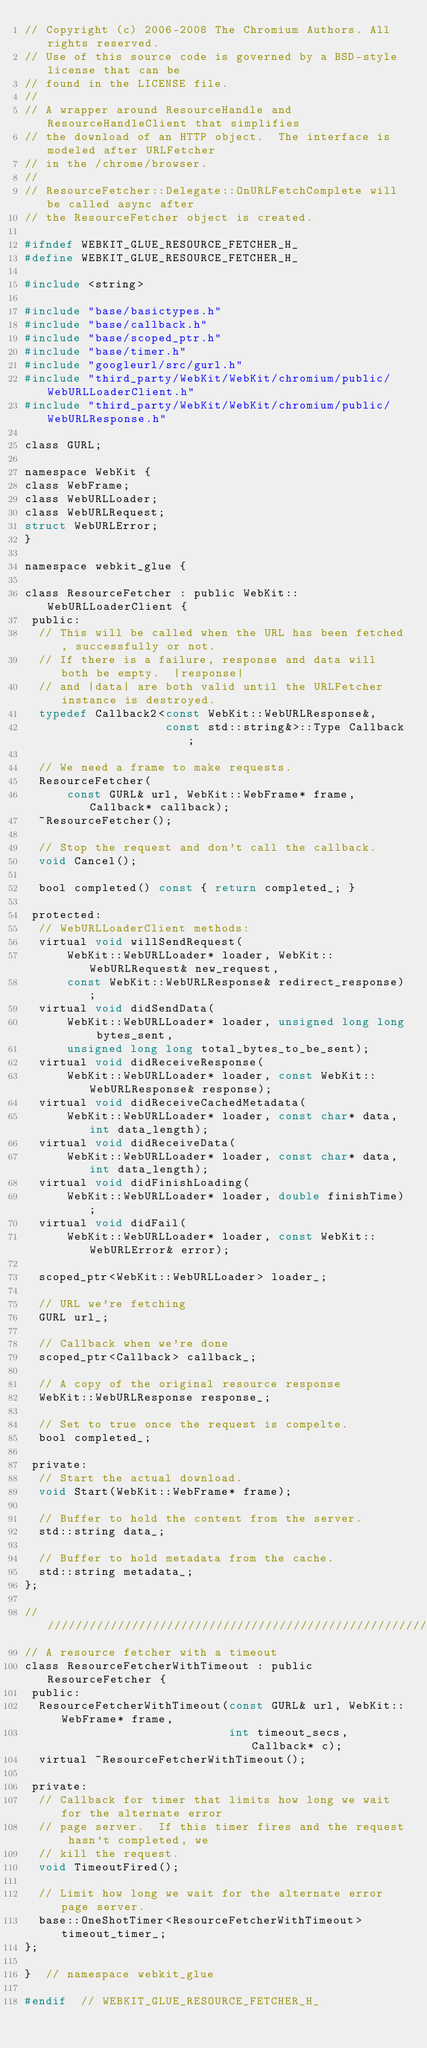Convert code to text. <code><loc_0><loc_0><loc_500><loc_500><_C_>// Copyright (c) 2006-2008 The Chromium Authors. All rights reserved.
// Use of this source code is governed by a BSD-style license that can be
// found in the LICENSE file.
//
// A wrapper around ResourceHandle and ResourceHandleClient that simplifies
// the download of an HTTP object.  The interface is modeled after URLFetcher
// in the /chrome/browser.
//
// ResourceFetcher::Delegate::OnURLFetchComplete will be called async after
// the ResourceFetcher object is created.

#ifndef WEBKIT_GLUE_RESOURCE_FETCHER_H_
#define WEBKIT_GLUE_RESOURCE_FETCHER_H_

#include <string>

#include "base/basictypes.h"
#include "base/callback.h"
#include "base/scoped_ptr.h"
#include "base/timer.h"
#include "googleurl/src/gurl.h"
#include "third_party/WebKit/WebKit/chromium/public/WebURLLoaderClient.h"
#include "third_party/WebKit/WebKit/chromium/public/WebURLResponse.h"

class GURL;

namespace WebKit {
class WebFrame;
class WebURLLoader;
class WebURLRequest;
struct WebURLError;
}

namespace webkit_glue {

class ResourceFetcher : public WebKit::WebURLLoaderClient {
 public:
  // This will be called when the URL has been fetched, successfully or not.
  // If there is a failure, response and data will both be empty.  |response|
  // and |data| are both valid until the URLFetcher instance is destroyed.
  typedef Callback2<const WebKit::WebURLResponse&,
                    const std::string&>::Type Callback;

  // We need a frame to make requests.
  ResourceFetcher(
      const GURL& url, WebKit::WebFrame* frame, Callback* callback);
  ~ResourceFetcher();

  // Stop the request and don't call the callback.
  void Cancel();

  bool completed() const { return completed_; }

 protected:
  // WebURLLoaderClient methods:
  virtual void willSendRequest(
      WebKit::WebURLLoader* loader, WebKit::WebURLRequest& new_request,
      const WebKit::WebURLResponse& redirect_response);
  virtual void didSendData(
      WebKit::WebURLLoader* loader, unsigned long long bytes_sent,
      unsigned long long total_bytes_to_be_sent);
  virtual void didReceiveResponse(
      WebKit::WebURLLoader* loader, const WebKit::WebURLResponse& response);
  virtual void didReceiveCachedMetadata(
      WebKit::WebURLLoader* loader, const char* data, int data_length);
  virtual void didReceiveData(
      WebKit::WebURLLoader* loader, const char* data, int data_length);
  virtual void didFinishLoading(
      WebKit::WebURLLoader* loader, double finishTime);
  virtual void didFail(
      WebKit::WebURLLoader* loader, const WebKit::WebURLError& error);

  scoped_ptr<WebKit::WebURLLoader> loader_;

  // URL we're fetching
  GURL url_;

  // Callback when we're done
  scoped_ptr<Callback> callback_;

  // A copy of the original resource response
  WebKit::WebURLResponse response_;

  // Set to true once the request is compelte.
  bool completed_;

 private:
  // Start the actual download.
  void Start(WebKit::WebFrame* frame);

  // Buffer to hold the content from the server.
  std::string data_;

  // Buffer to hold metadata from the cache.
  std::string metadata_;
};

/////////////////////////////////////////////////////////////////////////////
// A resource fetcher with a timeout
class ResourceFetcherWithTimeout : public ResourceFetcher {
 public:
  ResourceFetcherWithTimeout(const GURL& url, WebKit::WebFrame* frame,
                             int timeout_secs, Callback* c);
  virtual ~ResourceFetcherWithTimeout();

 private:
  // Callback for timer that limits how long we wait for the alternate error
  // page server.  If this timer fires and the request hasn't completed, we
  // kill the request.
  void TimeoutFired();

  // Limit how long we wait for the alternate error page server.
  base::OneShotTimer<ResourceFetcherWithTimeout> timeout_timer_;
};

}  // namespace webkit_glue

#endif  // WEBKIT_GLUE_RESOURCE_FETCHER_H_
</code> 